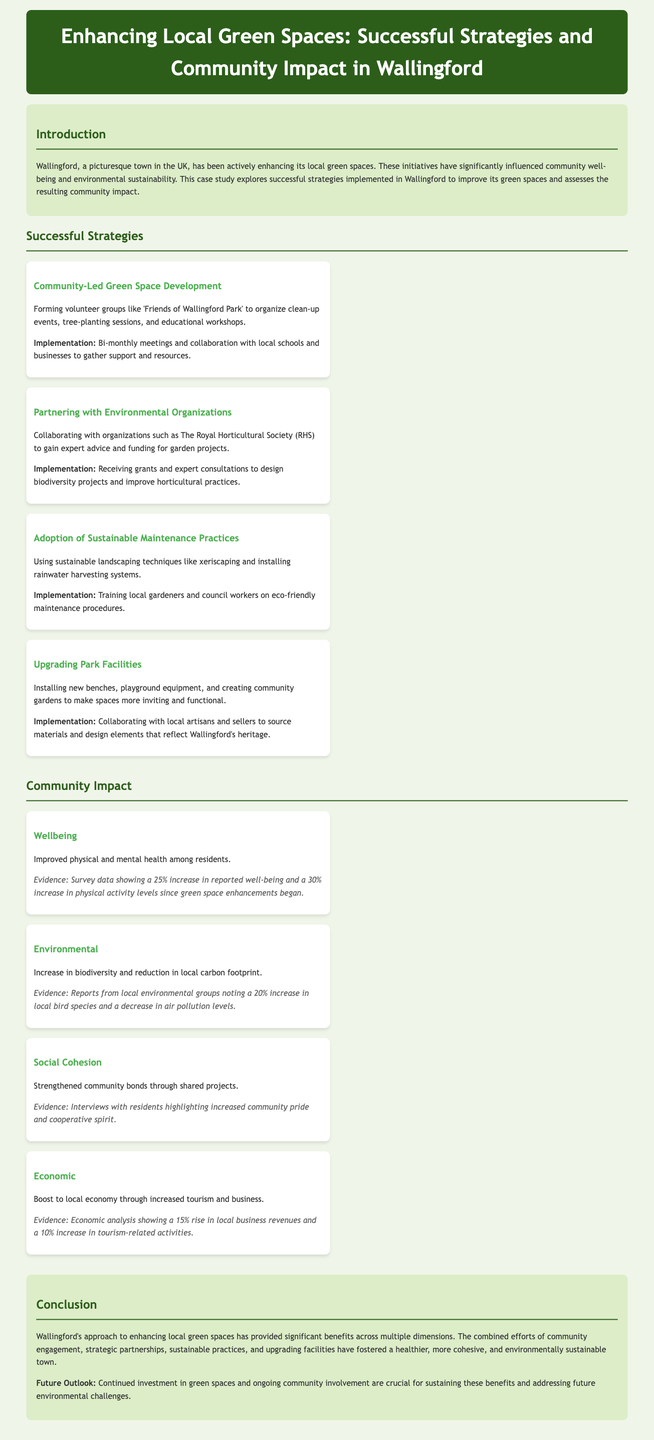what initiatives are mentioned to enhance green spaces? The document outlines several initiatives including community-led development, partnering with environmental organizations, sustainable maintenance practices, and upgrading park facilities.
Answer: community-led development, partnering with environmental organizations, sustainable maintenance practices, upgrading park facilities what percentage increase in reported well-being is noted? The evidence states there is a 25% increase in reported well-being among residents after the enhancements.
Answer: 25% which organization provided expert advice and funding? The text mentions The Royal Horticultural Society (RHS) as the organization involved.
Answer: The Royal Horticultural Society what is one sustainable landscaping technique mentioned? The document lists xeriscaping as one sustainable landscaping technique used in Wallingford.
Answer: xeriscaping what was the economic impact reported in terms of local business revenues? The impact analysis indicates a 15% rise in local business revenues due to the enhancements.
Answer: 15% how often do volunteer groups meet according to the implementation details? The document specifies that volunteer groups have bi-monthly meetings.
Answer: bi-monthly what two types of maintenance practices are emphasized? Sustainable landscaping and eco-friendly maintenance procedures are emphasized.
Answer: sustainable landscaping, eco-friendly maintenance procedures what is the conclusion about Wallingford's approach? The conclusion states that the approach has provided significant benefits across multiple dimensions.
Answer: significant benefits across multiple dimensions how were park facilities upgraded? The document explains that new benches and equipment were installed and community gardens were created to upgrade facilities.
Answer: new benches, playground equipment, community gardens 